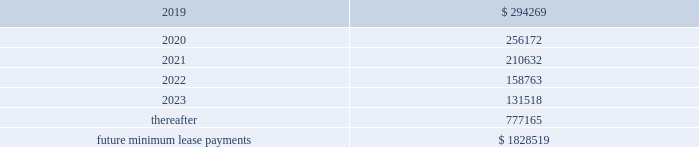Business subsequent to the acquisition .
The liabilities for these payments are classified as level 3 liabilities because the related fair value measurement , which is determined using an income approach , includes significant inputs not observable in the market .
Financial assets and liabilities not measured at fair value our debt is reflected on the consolidated balance sheets at cost .
Based on market conditions as of december 31 , 2018 and 2017 , the fair value of our credit agreement borrowings reasonably approximated the carrying values of $ 1.7 billion and $ 2.0 billion , respectively .
In addition , based on market conditions , the fair values of the outstanding borrowings under the receivables facility reasonably approximated the carrying values of $ 110 million and $ 100 million at december 31 , 2018 and december 31 , 2017 , respectively .
As of december 31 , 2018 and december 31 , 2017 , the fair values of the u.s .
Notes ( 2023 ) were approximately $ 574 million and $ 615 million , respectively , compared to a carrying value of $ 600 million at each date .
As of december 31 , 2018 and december 31 , 2017 , the fair values of the euro notes ( 2024 ) were approximately $ 586 million and $ 658 million compared to carrying values of $ 573 million and $ 600 million , respectively .
As of december 31 , 2018 , the fair value of the euro notes ( 2026/28 ) approximated the carrying value of $ 1.1 billion .
The fair value measurements of the borrowings under our credit agreement and receivables facility are classified as level 2 within the fair value hierarchy since they are determined based upon significant inputs observable in the market , including interest rates on recent financing transactions with similar terms and maturities .
We estimated the fair value by calculating the upfront cash payment a market participant would require at december 31 , 2018 to assume these obligations .
The fair value of our u.s .
Notes ( 2023 ) is classified as level 1 within the fair value hierarchy since it is determined based upon observable market inputs including quoted market prices in an active market .
The fair values of our euro notes ( 2024 ) and euro notes ( 2026/28 ) are determined based upon observable market inputs including quoted market prices in markets that are not active , and therefore are classified as level 2 within the fair value hierarchy .
Note 13 .
Commitments and contingencies operating leases we are obligated under noncancelable operating leases for corporate office space , warehouse and distribution facilities , trucks and certain equipment .
The future minimum lease commitments under these leases at december 31 , 2018 are as follows ( in thousands ) : years ending december 31: .
Rental expense for operating leases was approximately $ 300 million , $ 247 million , and $ 212 million during the years ended december 31 , 2018 , 2017 and 2016 , respectively .
We guarantee the residual values of the majority of our truck and equipment operating leases .
The residual values decline over the lease terms to a defined percentage of original cost .
In the event the lessor does not realize the residual value when a piece of equipment is sold , we would be responsible for a portion of the shortfall .
Similarly , if the lessor realizes more than the residual value when a piece of equipment is sold , we would be paid the amount realized over the residual value .
Had we terminated all of our operating leases subject to these guarantees at december 31 , 2018 , our portion of the guaranteed residual value would have totaled approximately $ 76 million .
We have not recorded a liability for the guaranteed residual value of equipment under operating leases as the recovery on disposition of the equipment under the leases is expected to approximate the guaranteed residual value .
Litigation and related contingencies we have certain contingencies resulting from litigation , claims and other commitments and are subject to a variety of environmental and pollution control laws and regulations incident to the ordinary course of business .
We currently expect that the resolution of such contingencies will not materially affect our financial position , results of operations or cash flows. .
What was the percentage change in rental expenses from 2017 to 2018? 
Computations: ((300 - 247) / 247)
Answer: 0.21457. Business subsequent to the acquisition .
The liabilities for these payments are classified as level 3 liabilities because the related fair value measurement , which is determined using an income approach , includes significant inputs not observable in the market .
Financial assets and liabilities not measured at fair value our debt is reflected on the consolidated balance sheets at cost .
Based on market conditions as of december 31 , 2018 and 2017 , the fair value of our credit agreement borrowings reasonably approximated the carrying values of $ 1.7 billion and $ 2.0 billion , respectively .
In addition , based on market conditions , the fair values of the outstanding borrowings under the receivables facility reasonably approximated the carrying values of $ 110 million and $ 100 million at december 31 , 2018 and december 31 , 2017 , respectively .
As of december 31 , 2018 and december 31 , 2017 , the fair values of the u.s .
Notes ( 2023 ) were approximately $ 574 million and $ 615 million , respectively , compared to a carrying value of $ 600 million at each date .
As of december 31 , 2018 and december 31 , 2017 , the fair values of the euro notes ( 2024 ) were approximately $ 586 million and $ 658 million compared to carrying values of $ 573 million and $ 600 million , respectively .
As of december 31 , 2018 , the fair value of the euro notes ( 2026/28 ) approximated the carrying value of $ 1.1 billion .
The fair value measurements of the borrowings under our credit agreement and receivables facility are classified as level 2 within the fair value hierarchy since they are determined based upon significant inputs observable in the market , including interest rates on recent financing transactions with similar terms and maturities .
We estimated the fair value by calculating the upfront cash payment a market participant would require at december 31 , 2018 to assume these obligations .
The fair value of our u.s .
Notes ( 2023 ) is classified as level 1 within the fair value hierarchy since it is determined based upon observable market inputs including quoted market prices in an active market .
The fair values of our euro notes ( 2024 ) and euro notes ( 2026/28 ) are determined based upon observable market inputs including quoted market prices in markets that are not active , and therefore are classified as level 2 within the fair value hierarchy .
Note 13 .
Commitments and contingencies operating leases we are obligated under noncancelable operating leases for corporate office space , warehouse and distribution facilities , trucks and certain equipment .
The future minimum lease commitments under these leases at december 31 , 2018 are as follows ( in thousands ) : years ending december 31: .
Rental expense for operating leases was approximately $ 300 million , $ 247 million , and $ 212 million during the years ended december 31 , 2018 , 2017 and 2016 , respectively .
We guarantee the residual values of the majority of our truck and equipment operating leases .
The residual values decline over the lease terms to a defined percentage of original cost .
In the event the lessor does not realize the residual value when a piece of equipment is sold , we would be responsible for a portion of the shortfall .
Similarly , if the lessor realizes more than the residual value when a piece of equipment is sold , we would be paid the amount realized over the residual value .
Had we terminated all of our operating leases subject to these guarantees at december 31 , 2018 , our portion of the guaranteed residual value would have totaled approximately $ 76 million .
We have not recorded a liability for the guaranteed residual value of equipment under operating leases as the recovery on disposition of the equipment under the leases is expected to approximate the guaranteed residual value .
Litigation and related contingencies we have certain contingencies resulting from litigation , claims and other commitments and are subject to a variety of environmental and pollution control laws and regulations incident to the ordinary course of business .
We currently expect that the resolution of such contingencies will not materially affect our financial position , results of operations or cash flows. .
What was the cumulative total rental expense for operating leases from 2016 to 2018? 
Computations: (212 + (300 + 247))
Answer: 759.0. Business subsequent to the acquisition .
The liabilities for these payments are classified as level 3 liabilities because the related fair value measurement , which is determined using an income approach , includes significant inputs not observable in the market .
Financial assets and liabilities not measured at fair value our debt is reflected on the consolidated balance sheets at cost .
Based on market conditions as of december 31 , 2018 and 2017 , the fair value of our credit agreement borrowings reasonably approximated the carrying values of $ 1.7 billion and $ 2.0 billion , respectively .
In addition , based on market conditions , the fair values of the outstanding borrowings under the receivables facility reasonably approximated the carrying values of $ 110 million and $ 100 million at december 31 , 2018 and december 31 , 2017 , respectively .
As of december 31 , 2018 and december 31 , 2017 , the fair values of the u.s .
Notes ( 2023 ) were approximately $ 574 million and $ 615 million , respectively , compared to a carrying value of $ 600 million at each date .
As of december 31 , 2018 and december 31 , 2017 , the fair values of the euro notes ( 2024 ) were approximately $ 586 million and $ 658 million compared to carrying values of $ 573 million and $ 600 million , respectively .
As of december 31 , 2018 , the fair value of the euro notes ( 2026/28 ) approximated the carrying value of $ 1.1 billion .
The fair value measurements of the borrowings under our credit agreement and receivables facility are classified as level 2 within the fair value hierarchy since they are determined based upon significant inputs observable in the market , including interest rates on recent financing transactions with similar terms and maturities .
We estimated the fair value by calculating the upfront cash payment a market participant would require at december 31 , 2018 to assume these obligations .
The fair value of our u.s .
Notes ( 2023 ) is classified as level 1 within the fair value hierarchy since it is determined based upon observable market inputs including quoted market prices in an active market .
The fair values of our euro notes ( 2024 ) and euro notes ( 2026/28 ) are determined based upon observable market inputs including quoted market prices in markets that are not active , and therefore are classified as level 2 within the fair value hierarchy .
Note 13 .
Commitments and contingencies operating leases we are obligated under noncancelable operating leases for corporate office space , warehouse and distribution facilities , trucks and certain equipment .
The future minimum lease commitments under these leases at december 31 , 2018 are as follows ( in thousands ) : years ending december 31: .
Rental expense for operating leases was approximately $ 300 million , $ 247 million , and $ 212 million during the years ended december 31 , 2018 , 2017 and 2016 , respectively .
We guarantee the residual values of the majority of our truck and equipment operating leases .
The residual values decline over the lease terms to a defined percentage of original cost .
In the event the lessor does not realize the residual value when a piece of equipment is sold , we would be responsible for a portion of the shortfall .
Similarly , if the lessor realizes more than the residual value when a piece of equipment is sold , we would be paid the amount realized over the residual value .
Had we terminated all of our operating leases subject to these guarantees at december 31 , 2018 , our portion of the guaranteed residual value would have totaled approximately $ 76 million .
We have not recorded a liability for the guaranteed residual value of equipment under operating leases as the recovery on disposition of the equipment under the leases is expected to approximate the guaranteed residual value .
Litigation and related contingencies we have certain contingencies resulting from litigation , claims and other commitments and are subject to a variety of environmental and pollution control laws and regulations incident to the ordinary course of business .
We currently expect that the resolution of such contingencies will not materially affect our financial position , results of operations or cash flows. .
At december 31 , 2018 what was the percent of the total future minimum lease commitments under the leases that was due in 2020? 
Computations: (256172 / 1828519)
Answer: 0.1401. 